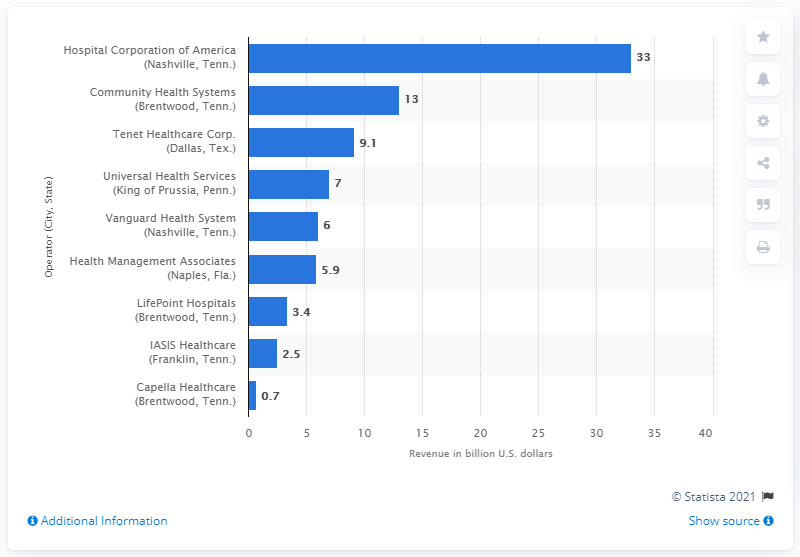Draw attention to some important aspects in this diagram. The total revenue of the Hospital Corporation of America in 2012 was $33 million. 